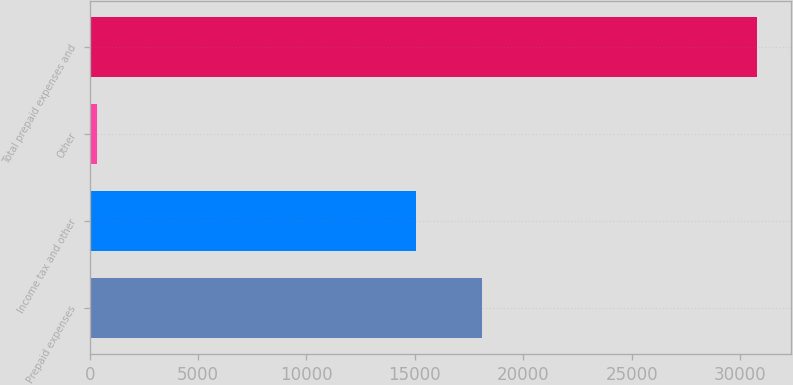Convert chart to OTSL. <chart><loc_0><loc_0><loc_500><loc_500><bar_chart><fcel>Prepaid expenses<fcel>Income tax and other<fcel>Other<fcel>Total prepaid expenses and<nl><fcel>18102.9<fcel>15056<fcel>326<fcel>30795<nl></chart> 